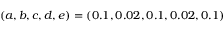Convert formula to latex. <formula><loc_0><loc_0><loc_500><loc_500>( a , b , c , d , e ) = ( 0 . 1 , 0 . 0 2 , 0 . 1 , 0 . 0 2 , 0 . 1 )</formula> 